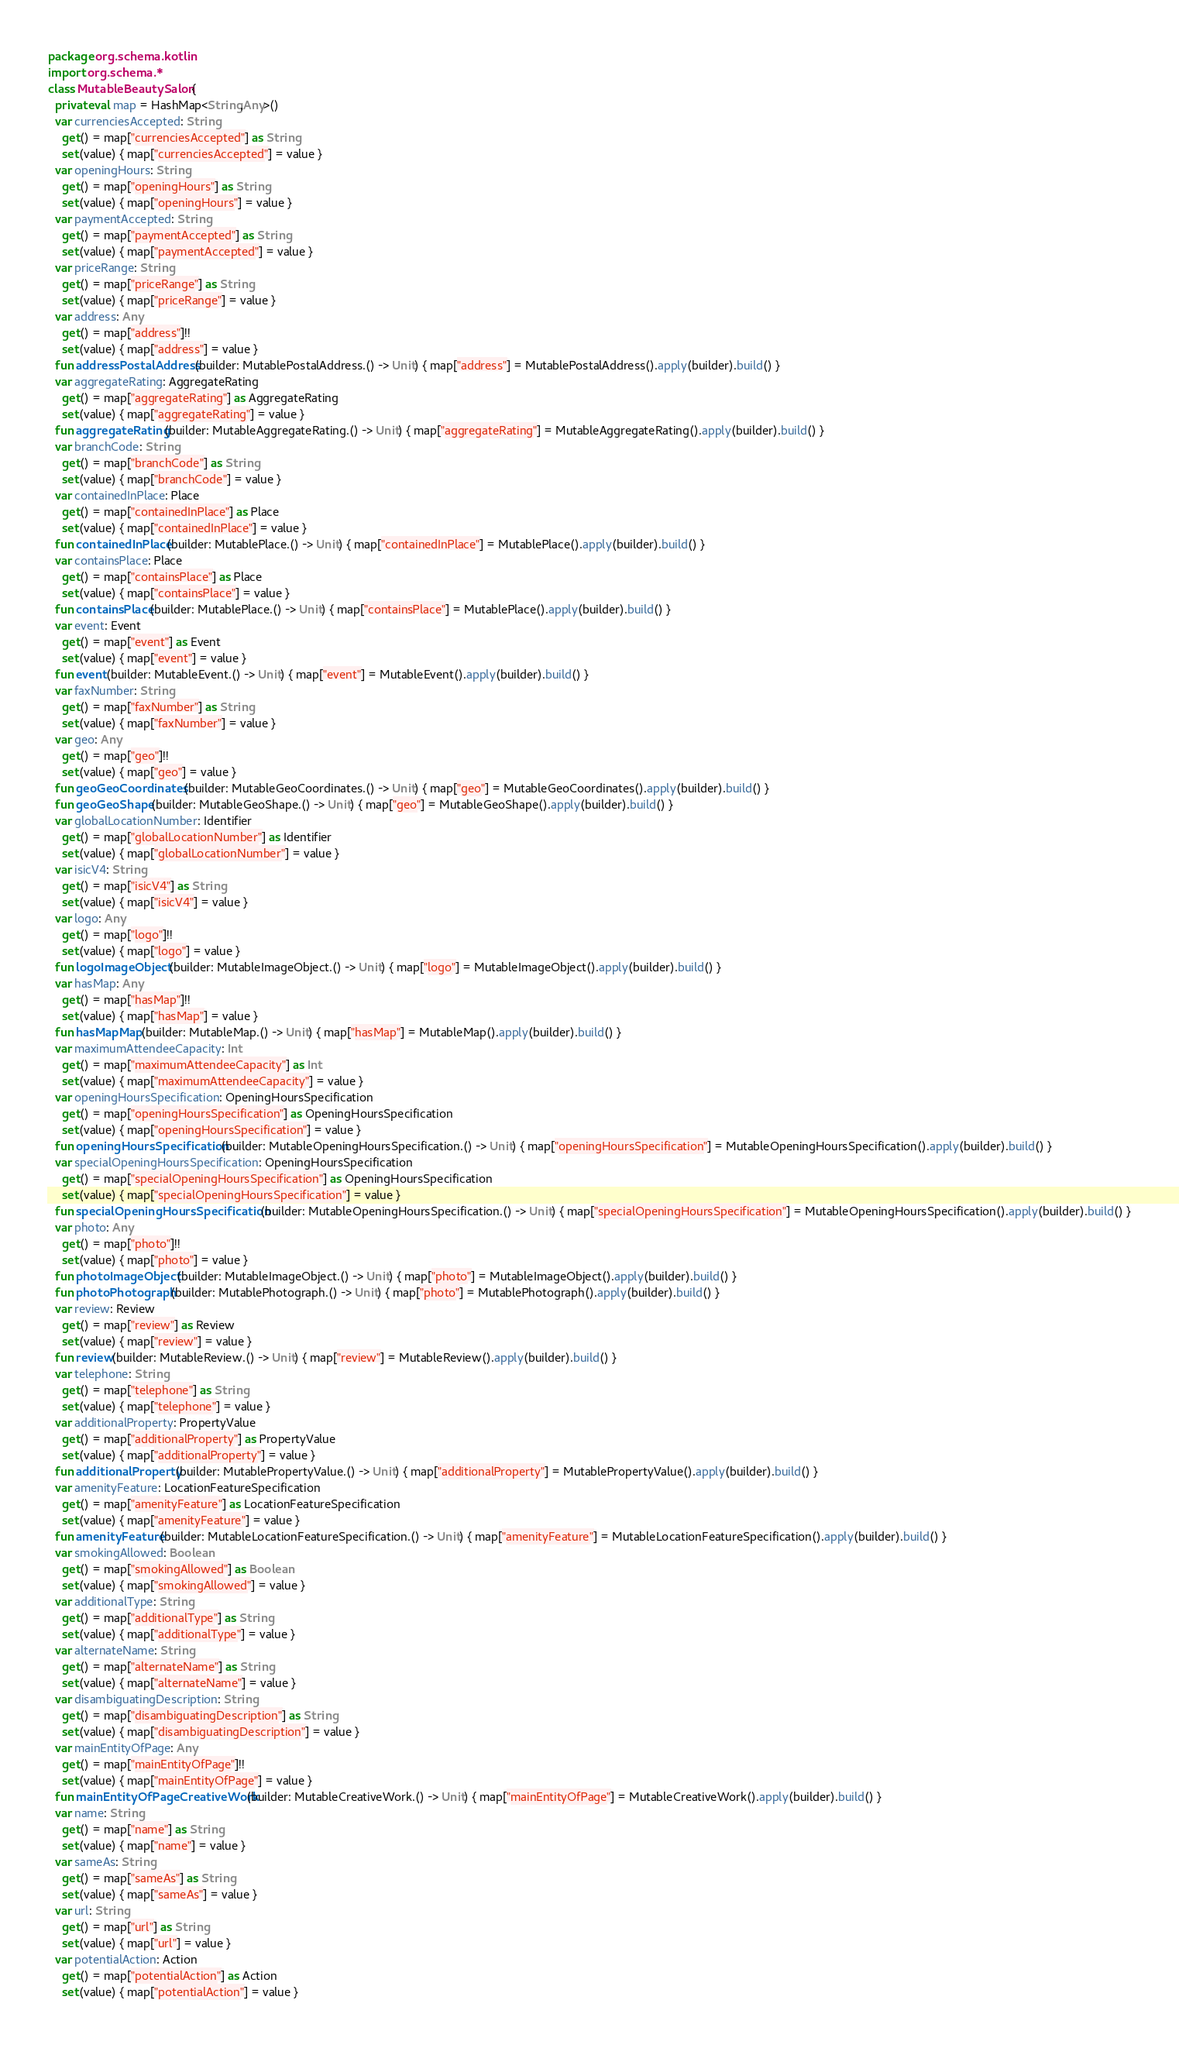Convert code to text. <code><loc_0><loc_0><loc_500><loc_500><_Kotlin_>package org.schema.kotlin
import org.schema.*
class MutableBeautySalon {
  private val map = HashMap<String,Any>()
  var currenciesAccepted: String
    get() = map["currenciesAccepted"] as String
    set(value) { map["currenciesAccepted"] = value }
  var openingHours: String
    get() = map["openingHours"] as String
    set(value) { map["openingHours"] = value }
  var paymentAccepted: String
    get() = map["paymentAccepted"] as String
    set(value) { map["paymentAccepted"] = value }
  var priceRange: String
    get() = map["priceRange"] as String
    set(value) { map["priceRange"] = value }
  var address: Any
    get() = map["address"]!!
    set(value) { map["address"] = value }
  fun addressPostalAddress(builder: MutablePostalAddress.() -> Unit) { map["address"] = MutablePostalAddress().apply(builder).build() }
  var aggregateRating: AggregateRating
    get() = map["aggregateRating"] as AggregateRating
    set(value) { map["aggregateRating"] = value }
  fun aggregateRating(builder: MutableAggregateRating.() -> Unit) { map["aggregateRating"] = MutableAggregateRating().apply(builder).build() }
  var branchCode: String
    get() = map["branchCode"] as String
    set(value) { map["branchCode"] = value }
  var containedInPlace: Place
    get() = map["containedInPlace"] as Place
    set(value) { map["containedInPlace"] = value }
  fun containedInPlace(builder: MutablePlace.() -> Unit) { map["containedInPlace"] = MutablePlace().apply(builder).build() }
  var containsPlace: Place
    get() = map["containsPlace"] as Place
    set(value) { map["containsPlace"] = value }
  fun containsPlace(builder: MutablePlace.() -> Unit) { map["containsPlace"] = MutablePlace().apply(builder).build() }
  var event: Event
    get() = map["event"] as Event
    set(value) { map["event"] = value }
  fun event(builder: MutableEvent.() -> Unit) { map["event"] = MutableEvent().apply(builder).build() }
  var faxNumber: String
    get() = map["faxNumber"] as String
    set(value) { map["faxNumber"] = value }
  var geo: Any
    get() = map["geo"]!!
    set(value) { map["geo"] = value }
  fun geoGeoCoordinates(builder: MutableGeoCoordinates.() -> Unit) { map["geo"] = MutableGeoCoordinates().apply(builder).build() }
  fun geoGeoShape(builder: MutableGeoShape.() -> Unit) { map["geo"] = MutableGeoShape().apply(builder).build() }
  var globalLocationNumber: Identifier
    get() = map["globalLocationNumber"] as Identifier
    set(value) { map["globalLocationNumber"] = value }
  var isicV4: String
    get() = map["isicV4"] as String
    set(value) { map["isicV4"] = value }
  var logo: Any
    get() = map["logo"]!!
    set(value) { map["logo"] = value }
  fun logoImageObject(builder: MutableImageObject.() -> Unit) { map["logo"] = MutableImageObject().apply(builder).build() }
  var hasMap: Any
    get() = map["hasMap"]!!
    set(value) { map["hasMap"] = value }
  fun hasMapMap(builder: MutableMap.() -> Unit) { map["hasMap"] = MutableMap().apply(builder).build() }
  var maximumAttendeeCapacity: Int
    get() = map["maximumAttendeeCapacity"] as Int
    set(value) { map["maximumAttendeeCapacity"] = value }
  var openingHoursSpecification: OpeningHoursSpecification
    get() = map["openingHoursSpecification"] as OpeningHoursSpecification
    set(value) { map["openingHoursSpecification"] = value }
  fun openingHoursSpecification(builder: MutableOpeningHoursSpecification.() -> Unit) { map["openingHoursSpecification"] = MutableOpeningHoursSpecification().apply(builder).build() }
  var specialOpeningHoursSpecification: OpeningHoursSpecification
    get() = map["specialOpeningHoursSpecification"] as OpeningHoursSpecification
    set(value) { map["specialOpeningHoursSpecification"] = value }
  fun specialOpeningHoursSpecification(builder: MutableOpeningHoursSpecification.() -> Unit) { map["specialOpeningHoursSpecification"] = MutableOpeningHoursSpecification().apply(builder).build() }
  var photo: Any
    get() = map["photo"]!!
    set(value) { map["photo"] = value }
  fun photoImageObject(builder: MutableImageObject.() -> Unit) { map["photo"] = MutableImageObject().apply(builder).build() }
  fun photoPhotograph(builder: MutablePhotograph.() -> Unit) { map["photo"] = MutablePhotograph().apply(builder).build() }
  var review: Review
    get() = map["review"] as Review
    set(value) { map["review"] = value }
  fun review(builder: MutableReview.() -> Unit) { map["review"] = MutableReview().apply(builder).build() }
  var telephone: String
    get() = map["telephone"] as String
    set(value) { map["telephone"] = value }
  var additionalProperty: PropertyValue
    get() = map["additionalProperty"] as PropertyValue
    set(value) { map["additionalProperty"] = value }
  fun additionalProperty(builder: MutablePropertyValue.() -> Unit) { map["additionalProperty"] = MutablePropertyValue().apply(builder).build() }
  var amenityFeature: LocationFeatureSpecification
    get() = map["amenityFeature"] as LocationFeatureSpecification
    set(value) { map["amenityFeature"] = value }
  fun amenityFeature(builder: MutableLocationFeatureSpecification.() -> Unit) { map["amenityFeature"] = MutableLocationFeatureSpecification().apply(builder).build() }
  var smokingAllowed: Boolean
    get() = map["smokingAllowed"] as Boolean
    set(value) { map["smokingAllowed"] = value }
  var additionalType: String
    get() = map["additionalType"] as String
    set(value) { map["additionalType"] = value }
  var alternateName: String
    get() = map["alternateName"] as String
    set(value) { map["alternateName"] = value }
  var disambiguatingDescription: String
    get() = map["disambiguatingDescription"] as String
    set(value) { map["disambiguatingDescription"] = value }
  var mainEntityOfPage: Any
    get() = map["mainEntityOfPage"]!!
    set(value) { map["mainEntityOfPage"] = value }
  fun mainEntityOfPageCreativeWork(builder: MutableCreativeWork.() -> Unit) { map["mainEntityOfPage"] = MutableCreativeWork().apply(builder).build() }
  var name: String
    get() = map["name"] as String
    set(value) { map["name"] = value }
  var sameAs: String
    get() = map["sameAs"] as String
    set(value) { map["sameAs"] = value }
  var url: String
    get() = map["url"] as String
    set(value) { map["url"] = value }
  var potentialAction: Action
    get() = map["potentialAction"] as Action
    set(value) { map["potentialAction"] = value }</code> 